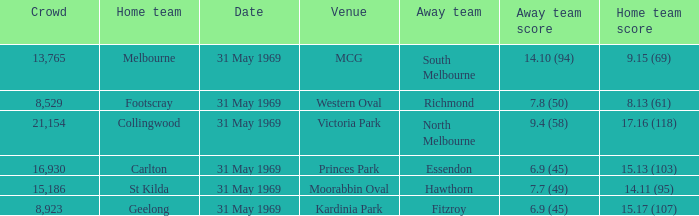17 (107), who was the visiting team? Fitzroy. 